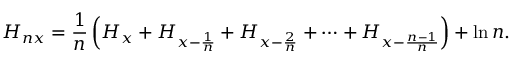<formula> <loc_0><loc_0><loc_500><loc_500>H _ { n x } = { \frac { 1 } { n } } \left ( H _ { x } + H _ { x - { \frac { 1 } { n } } } + H _ { x - { \frac { 2 } { n } } } + \cdots + H _ { x - { \frac { n - 1 } { n } } } \right ) + \ln n .</formula> 